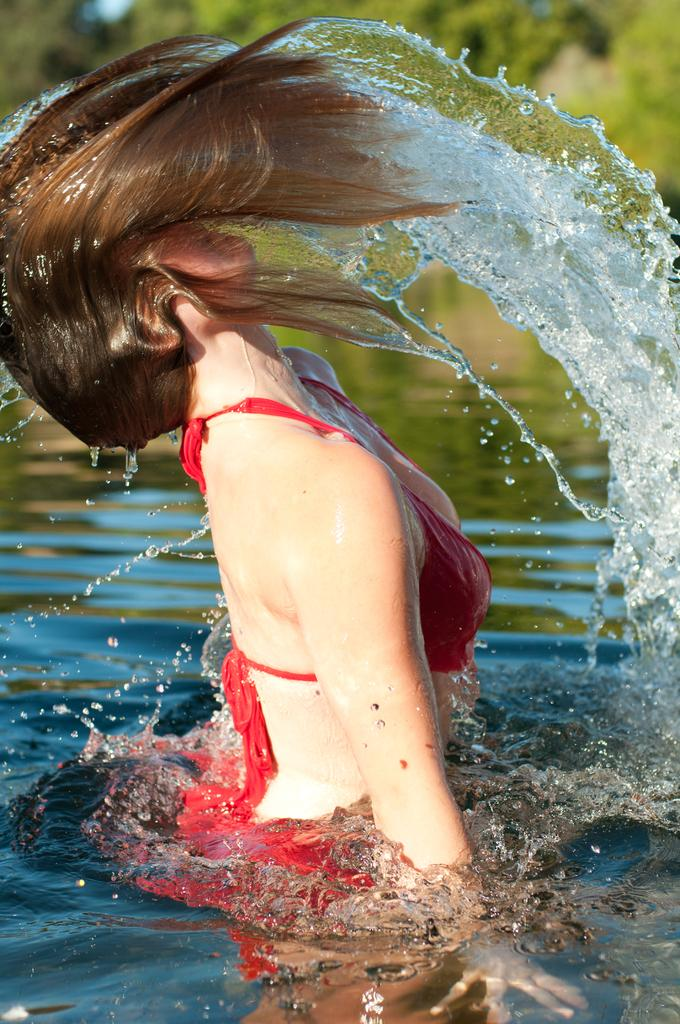Who is present in the image? There is a woman in the image. What is the woman's location in the image? The woman is in the water. What type of basket is the woman holding in the image? There is no basket present in the image; the woman is simply in the water. 